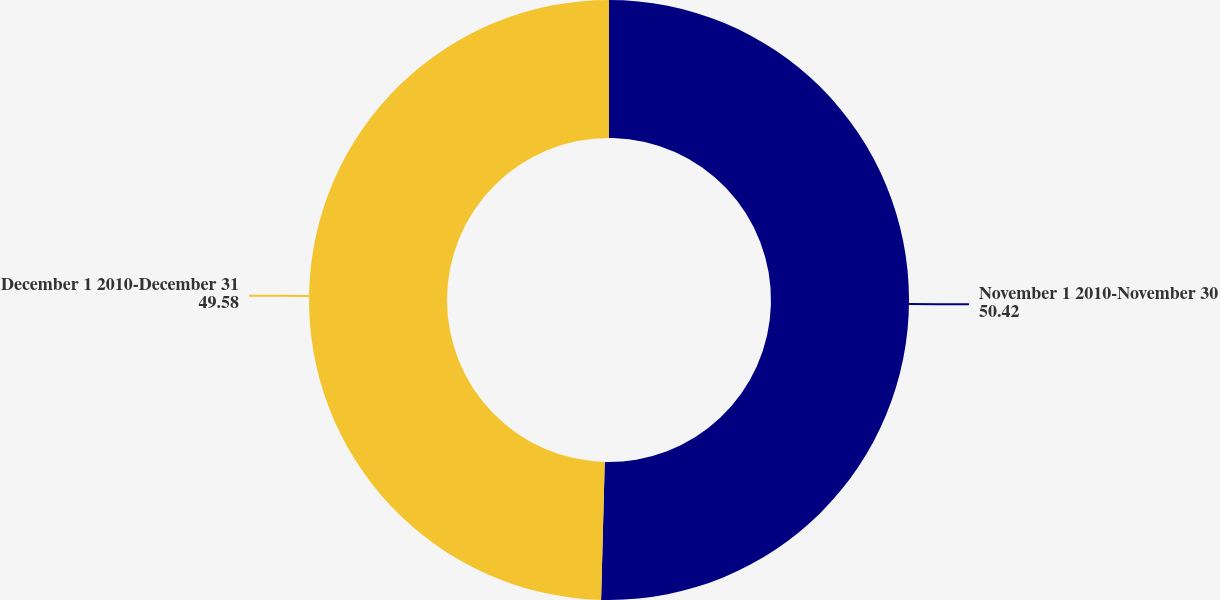<chart> <loc_0><loc_0><loc_500><loc_500><pie_chart><fcel>November 1 2010-November 30<fcel>December 1 2010-December 31<nl><fcel>50.42%<fcel>49.58%<nl></chart> 